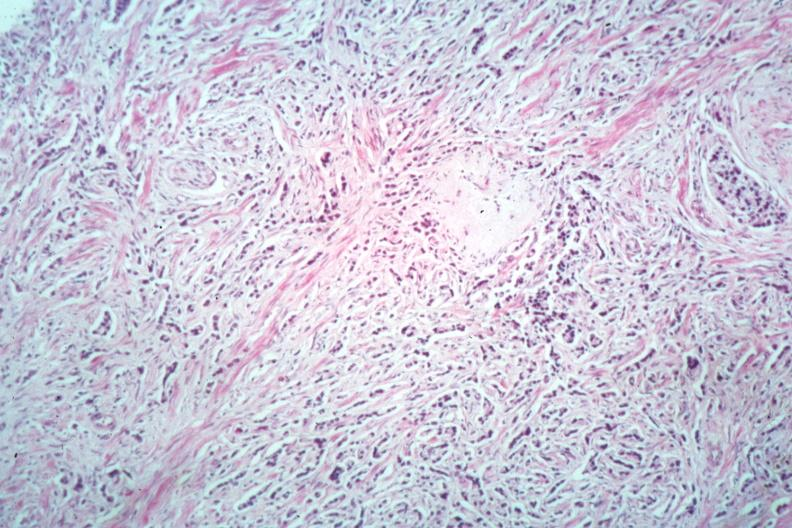what is present?
Answer the question using a single word or phrase. Adenocarcinoma 